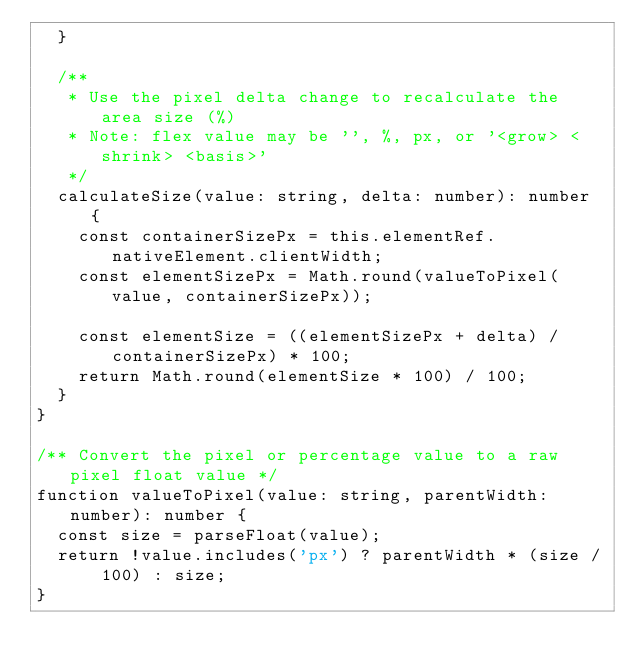Convert code to text. <code><loc_0><loc_0><loc_500><loc_500><_TypeScript_>  }

  /**
   * Use the pixel delta change to recalculate the area size (%)
   * Note: flex value may be '', %, px, or '<grow> <shrink> <basis>'
   */
  calculateSize(value: string, delta: number): number {
    const containerSizePx = this.elementRef.nativeElement.clientWidth;
    const elementSizePx = Math.round(valueToPixel(value, containerSizePx));

    const elementSize = ((elementSizePx + delta) / containerSizePx) * 100;
    return Math.round(elementSize * 100) / 100;
  }
}

/** Convert the pixel or percentage value to a raw pixel float value */
function valueToPixel(value: string, parentWidth: number): number {
  const size = parseFloat(value);
  return !value.includes('px') ? parentWidth * (size / 100) : size;
}
</code> 